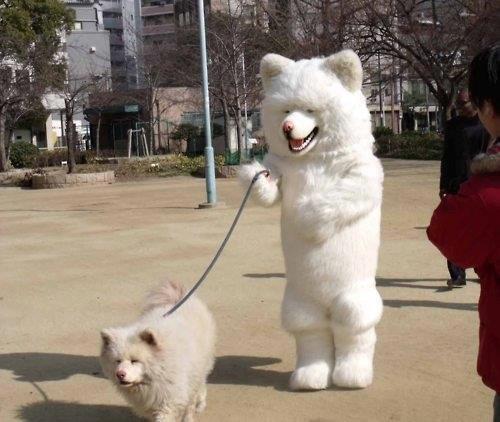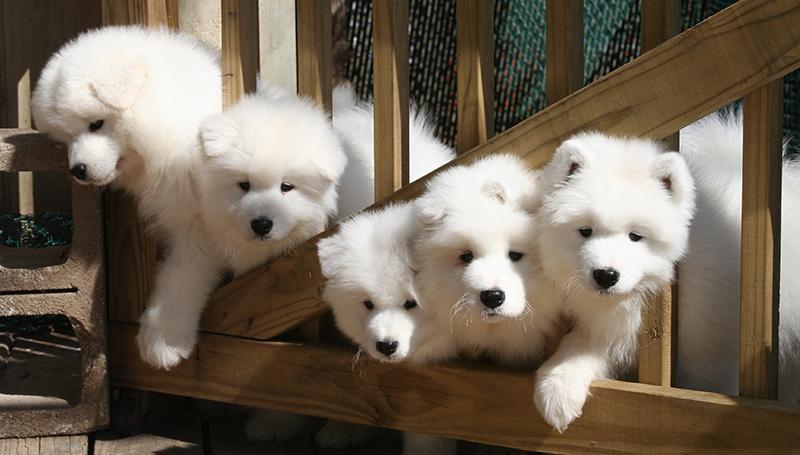The first image is the image on the left, the second image is the image on the right. Evaluate the accuracy of this statement regarding the images: "In one image, a large white dog is balanced on its hind legs beside a dark brown coffee table.". Is it true? Answer yes or no. No. The first image is the image on the left, the second image is the image on the right. Assess this claim about the two images: "There are at least three fluffy white dogs.". Correct or not? Answer yes or no. Yes. 